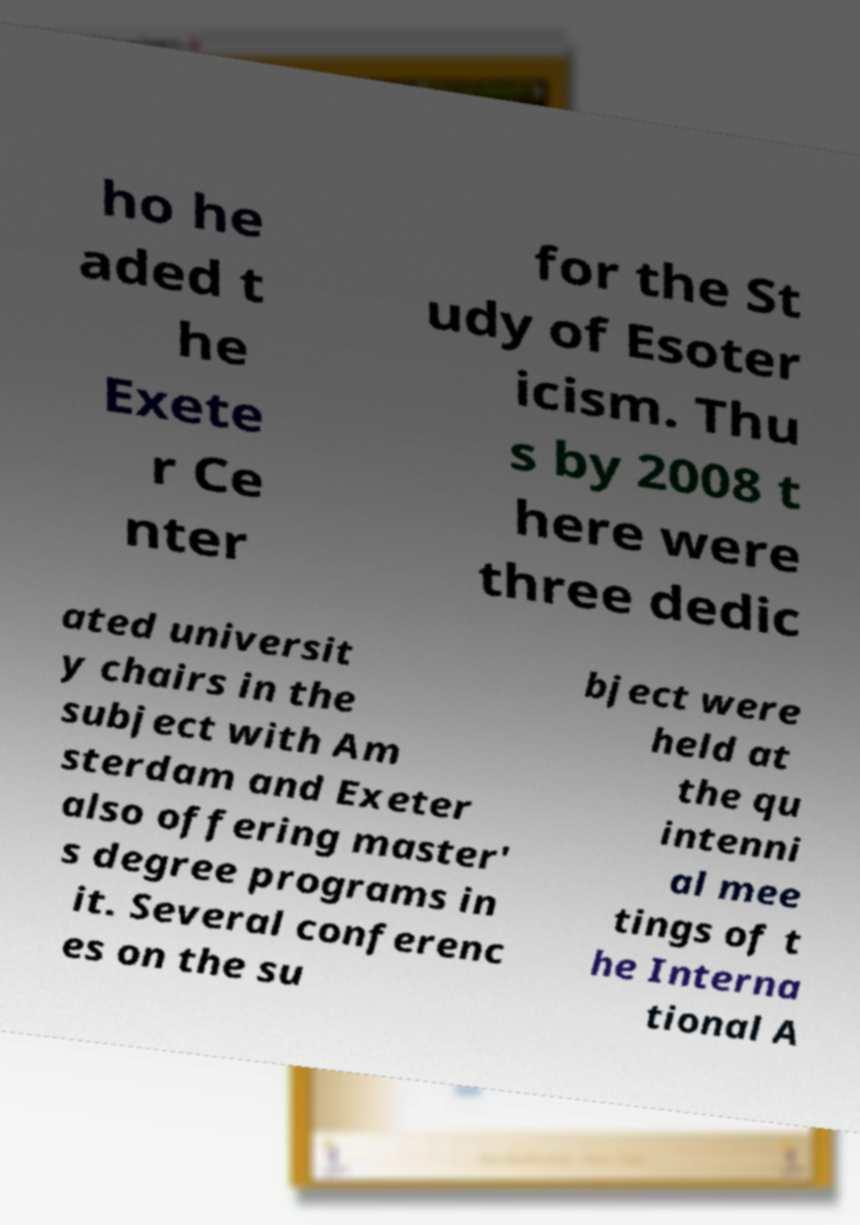There's text embedded in this image that I need extracted. Can you transcribe it verbatim? ho he aded t he Exete r Ce nter for the St udy of Esoter icism. Thu s by 2008 t here were three dedic ated universit y chairs in the subject with Am sterdam and Exeter also offering master' s degree programs in it. Several conferenc es on the su bject were held at the qu intenni al mee tings of t he Interna tional A 